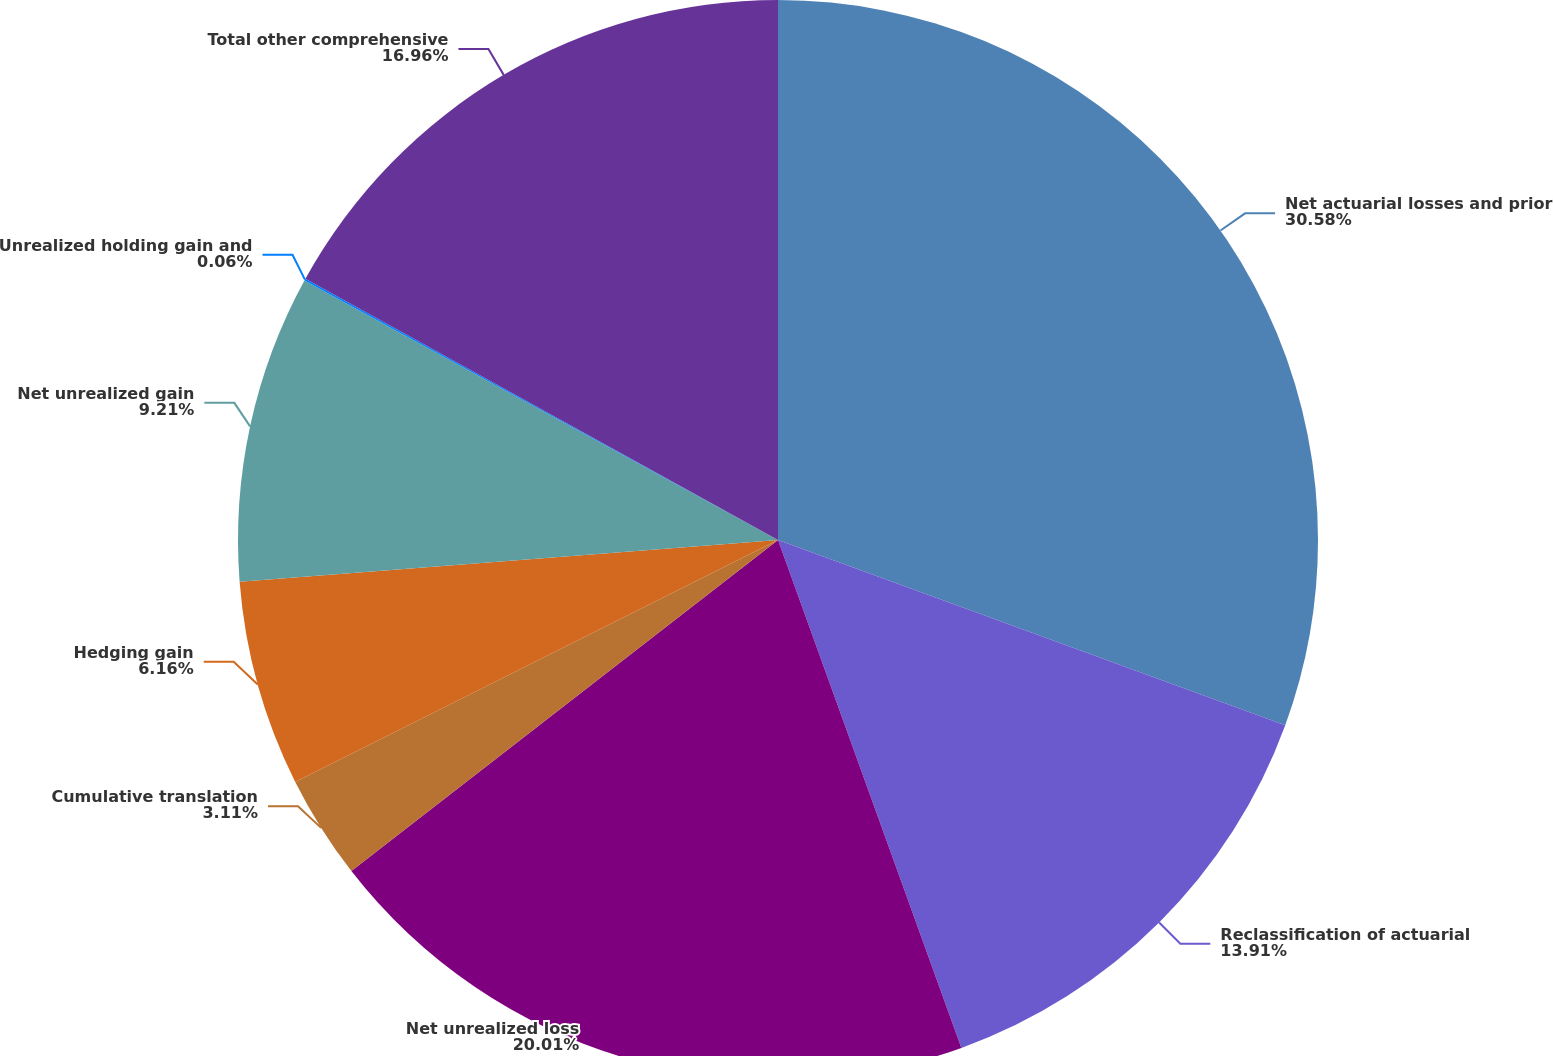Convert chart to OTSL. <chart><loc_0><loc_0><loc_500><loc_500><pie_chart><fcel>Net actuarial losses and prior<fcel>Reclassification of actuarial<fcel>Net unrealized loss<fcel>Cumulative translation<fcel>Hedging gain<fcel>Net unrealized gain<fcel>Unrealized holding gain and<fcel>Total other comprehensive<nl><fcel>30.57%<fcel>13.91%<fcel>20.01%<fcel>3.11%<fcel>6.16%<fcel>9.21%<fcel>0.06%<fcel>16.96%<nl></chart> 